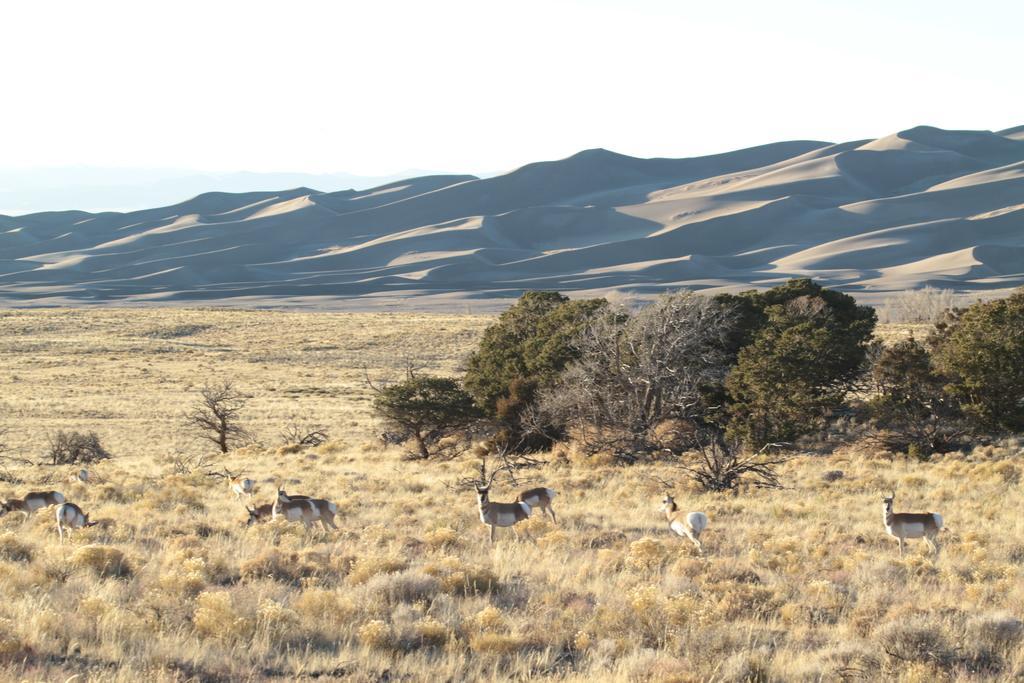Could you give a brief overview of what you see in this image? In this image, we can see some animals. We can see the ground covered with grass, plants and trees. We can see some hills and we can see the sky. 